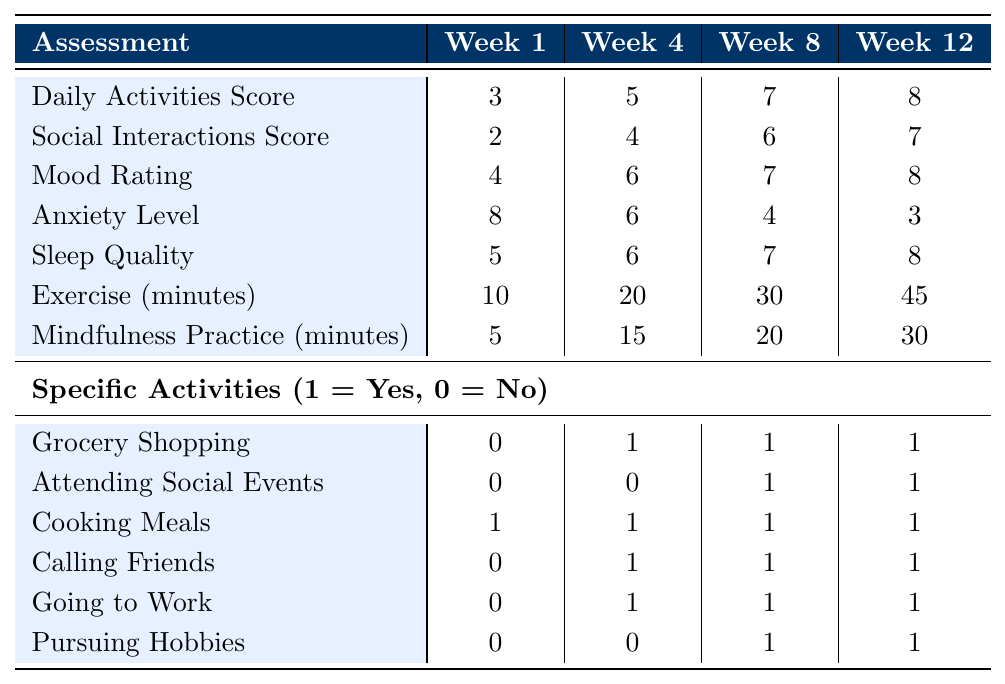What was the daily activities score in week 8? According to the table, the daily activities score for week 8 is listed directly. It shows a score of 7.
Answer: 7 What was the highest mood rating recorded during the therapy? By reviewing the mood rating across all weeks, week 12 has the highest mood rating of 8.
Answer: 8 Did the patient call friends in week 1? Referring to the specific activities section, it shows that the patient did not call friends in week 1, marked by a 0.
Answer: No What was the change in social interactions score from week 1 to week 12? The social interactions score for week 1 is 2 and for week 12 is 7. The difference is 7 - 2 = 5.
Answer: 5 What was the average anxiety level over the 12-week therapy? The anxiety levels in the weeks are 8, 6, 4, and 3. Summing these gives 8 + 6 + 4 + 3 = 21, with an average of 21/4 = 5.25.
Answer: 5.25 In which week did the patient start attending social events? The table shows that the patient did not attend social events in week 1 or week 4, but started attending in week 8 and continued in week 12, marked by 1.
Answer: Week 8 How many minutes of exercise did the patient engage in by week 12? Directly from the table, the exercise minutes recorded for week 12 show a total of 45 minutes of exercise.
Answer: 45 What is the difference in sleep quality between week 1 and week 12? Sleep quality for week 1 is 5, and for week 12 it is 8. The difference is 8 - 5 = 3.
Answer: 3 Did the patient pursue any hobbies in week 4? Checking the specific activities section, it indicates a 0 for pursuing hobbies in week 4, meaning no hobbies were pursued that week.
Answer: No What pattern can be observed in exercise minutes over the 12 weeks? The exercise minutes demonstrate a clear upward trend: 10 in week 1, increasing to 45 by week 12. It increased consistently across all time points.
Answer: Consistent increase 